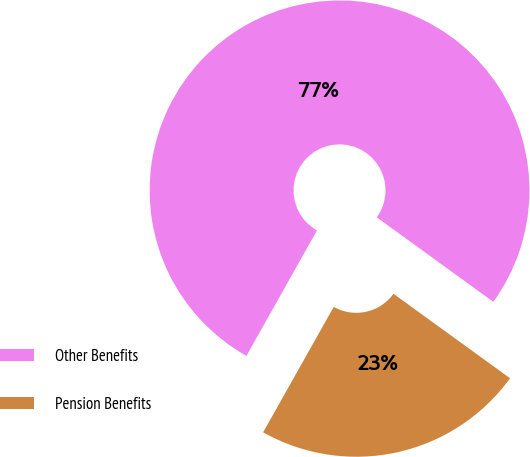<chart> <loc_0><loc_0><loc_500><loc_500><pie_chart><fcel>Other Benefits<fcel>Pension Benefits<nl><fcel>76.82%<fcel>23.18%<nl></chart> 